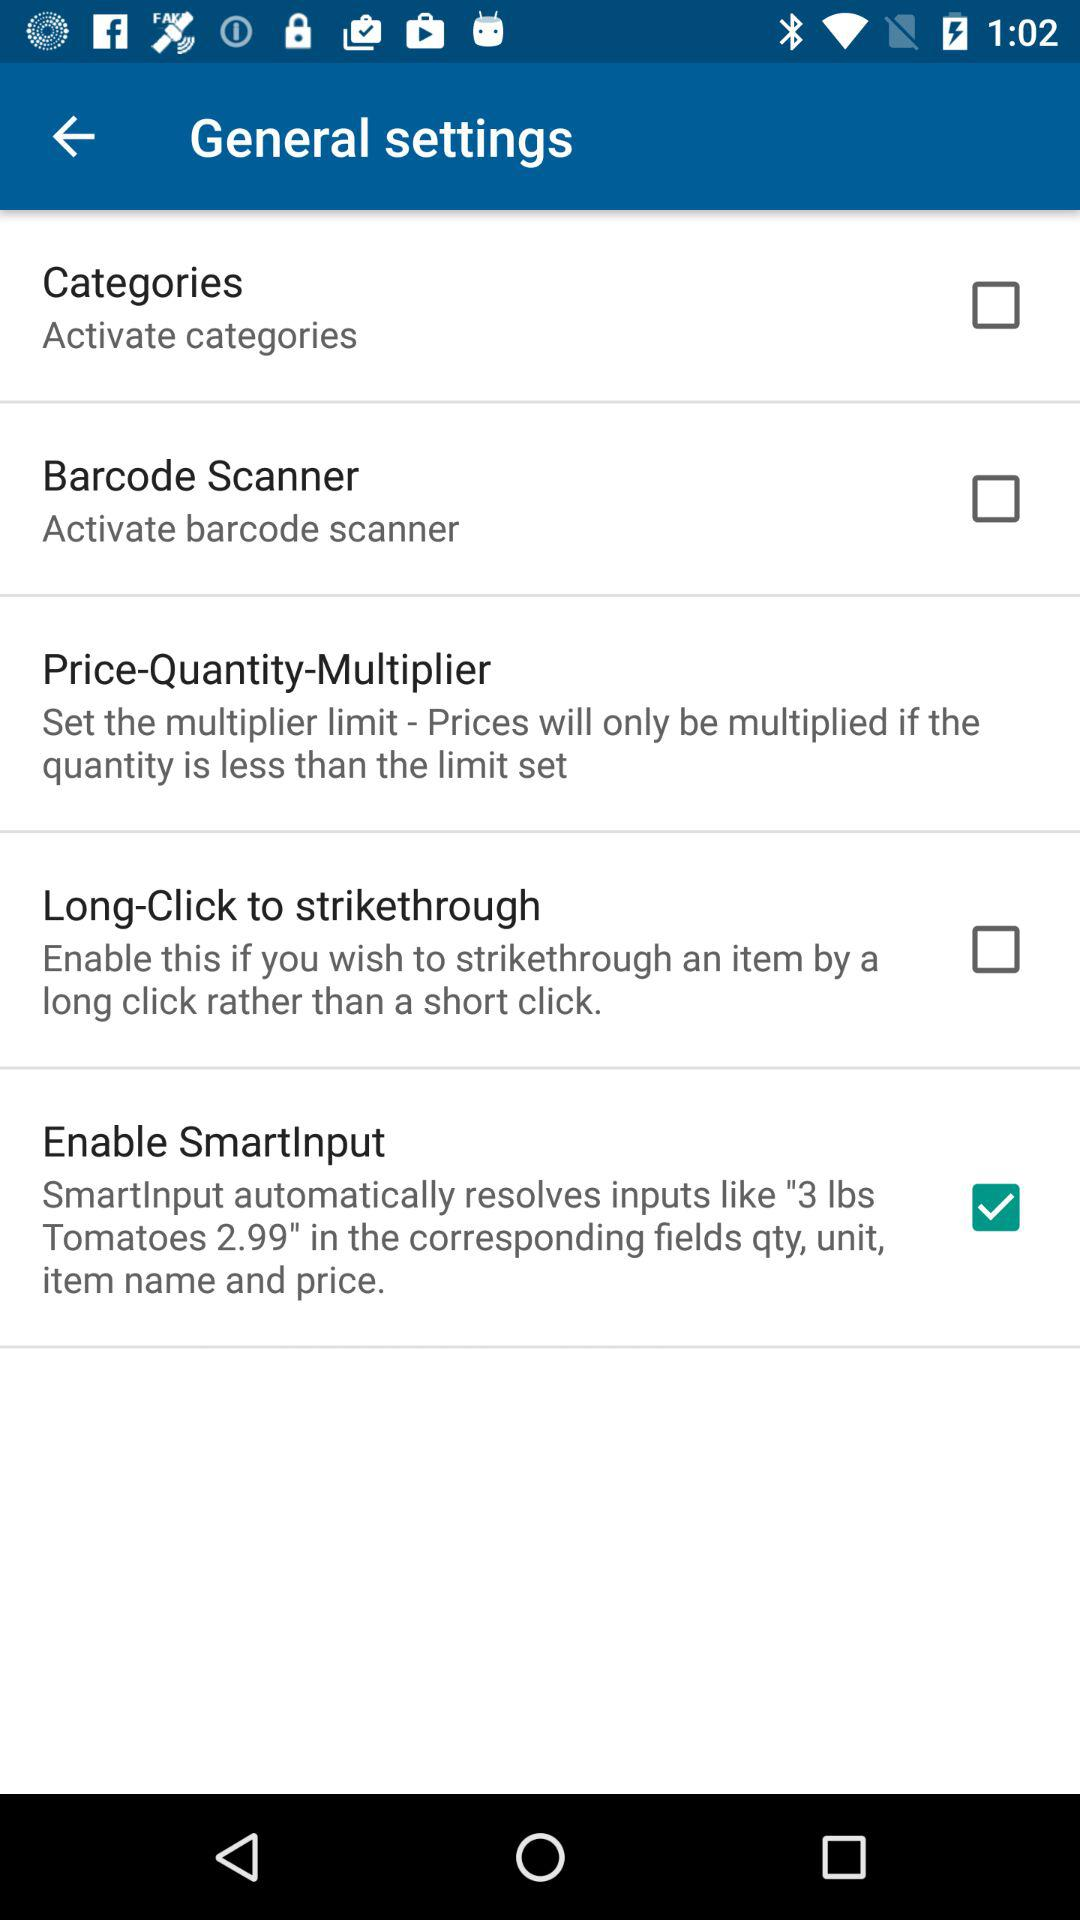How many settings are available under the general settings tab?
Answer the question using a single word or phrase. 5 